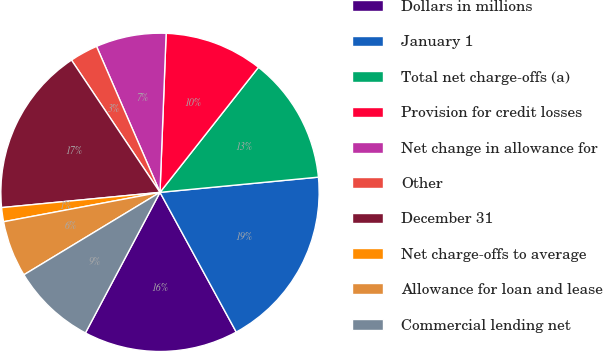<chart> <loc_0><loc_0><loc_500><loc_500><pie_chart><fcel>Dollars in millions<fcel>January 1<fcel>Total net charge-offs (a)<fcel>Provision for credit losses<fcel>Net change in allowance for<fcel>Other<fcel>December 31<fcel>Net charge-offs to average<fcel>Allowance for loan and lease<fcel>Commercial lending net<nl><fcel>15.71%<fcel>18.57%<fcel>12.86%<fcel>10.0%<fcel>7.14%<fcel>2.86%<fcel>17.14%<fcel>1.43%<fcel>5.71%<fcel>8.57%<nl></chart> 